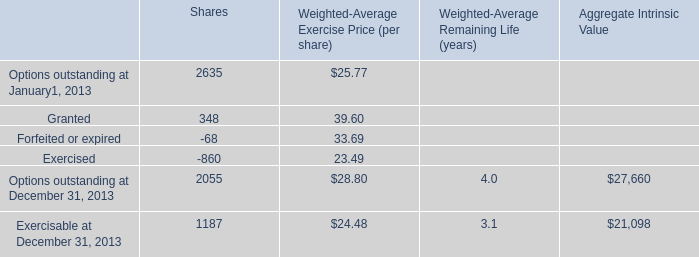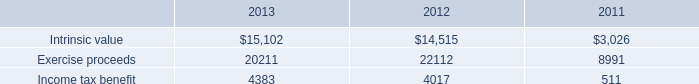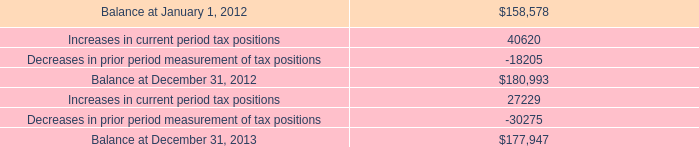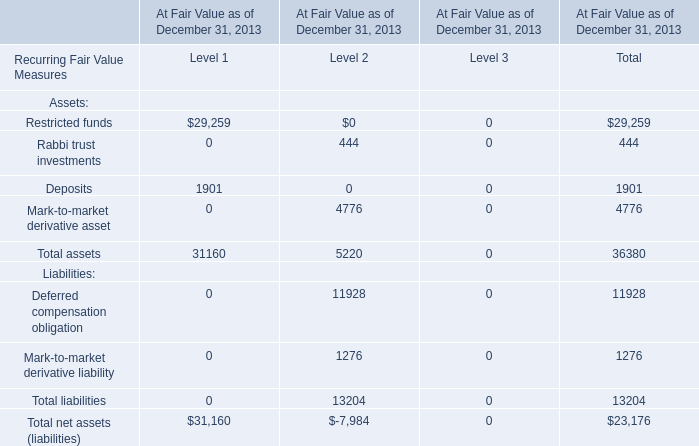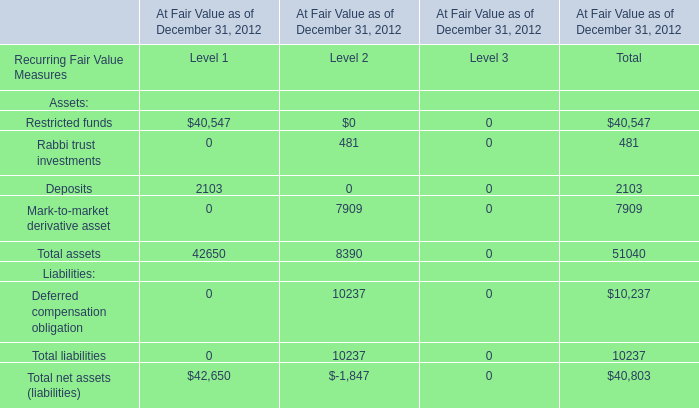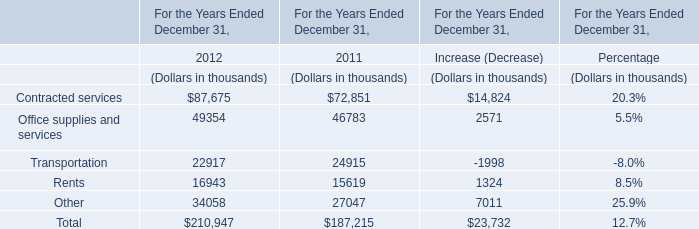what is the he company 2019s gross liability at the end of 2013 if including interest and penalties? 
Computations: (242 + 177947)
Answer: 178189.0. 